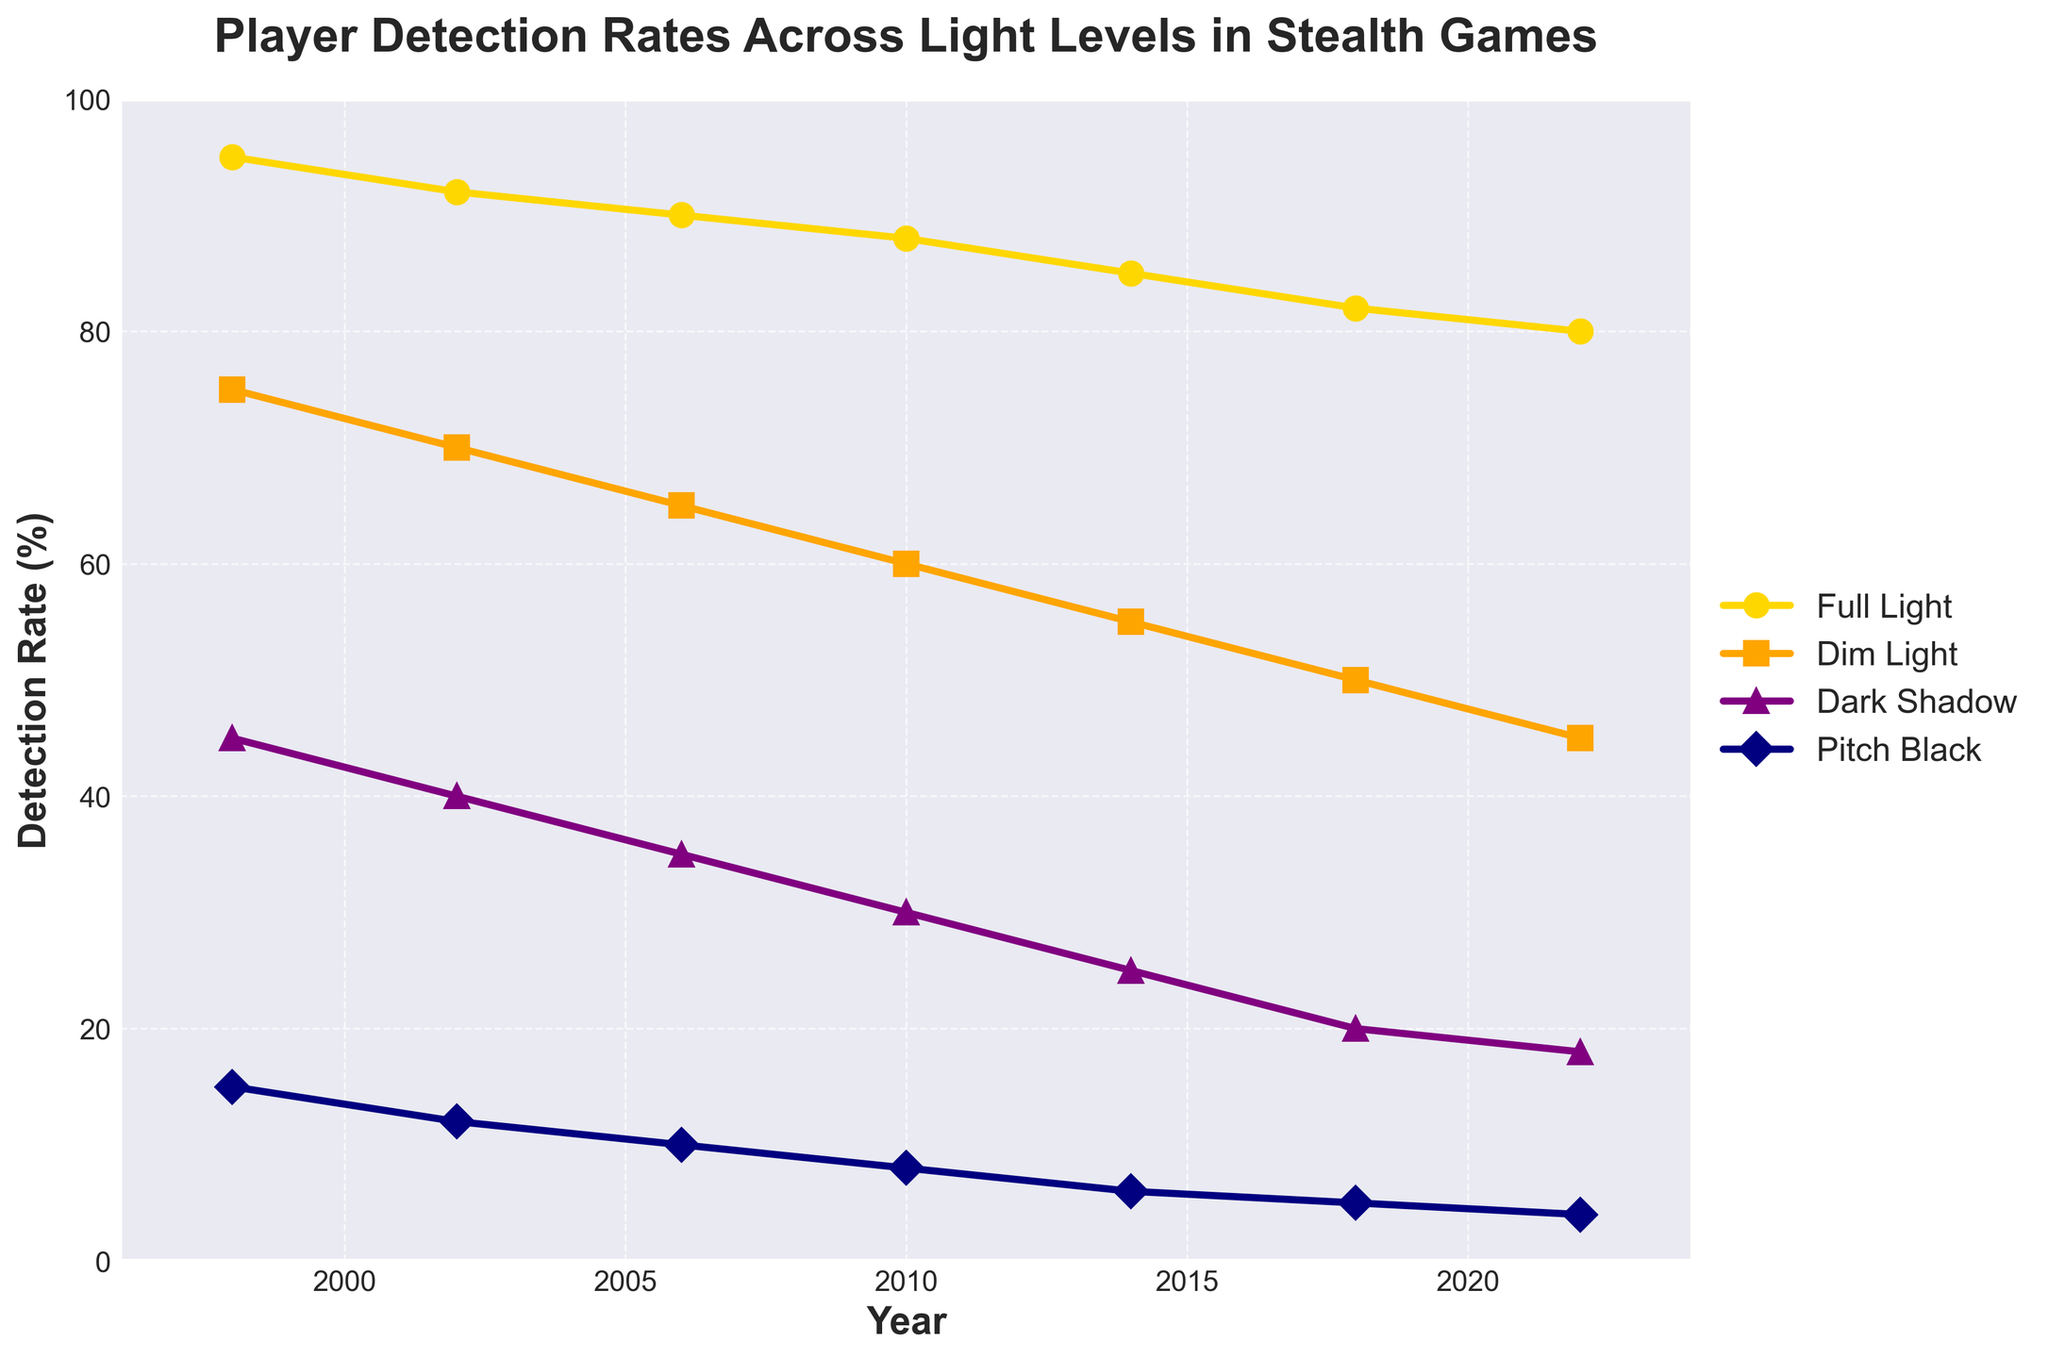What is the detection rate in Full Light and Pitch Black in 1998 combined? To find the combined detection rate for Full Light and Pitch Black in 1998, add the detection rates for these two light levels. Full Light in 1998 is 95%, and Pitch Black in 1998 is 15%. Therefore, the combined detection rate is 95 + 15 = 110.
Answer: 110 Which year had the smallest detection rate difference between Dim Light and Dark Shadow? Calculate the detection rate difference between Dim Light and Dark Shadow for each year and identify the smallest difference. 
- 1998: 75 - 45 = 30
- 2002: 70 - 40 = 30
- 2006: 65 - 35 = 30
- 2010: 60 - 30 = 30
- 2014: 55 - 25 = 30
- 2018: 50 - 20 = 30
- 2022: 45 - 18 = 27 
The smallest difference is in 2022.
Answer: 2022 In which year did the detection rate in Dark Shadow first drop below 30%? Locate the year when Dark Shadow detection rate falls below 30% for the first time. In 2010, the detection rate is 30%, and in 2014, it drops to 25%. Therefore, 2014 is the first year it drops below 30%.
Answer: 2014 Which light level has the steepest decline in detection rate over the given years? Determine the slope of the decline for each light level by subtracting the detection rate from 1998 to 2022 and dividing by the number of years (2022-1998 = 24).
- Full Light: (95 - 80) / 24 = 15 / 24 = 0.625
- Dim Light: (75 - 45) / 24 = 30 / 24 = 1.25
- Dark Shadow: (45 - 18) / 24 = 27 / 24 = 1.125
- Pitch Black: (15 - 4) / 24 = 11 / 24 = 0.458
Dim Light has the steepest decline.
Answer: Dim Light What is the average detection rate in Dark Shadow over the given years? Calculate the average detection rate in Dark Shadow by summing the detection rates and dividing by the number of years.
(45 + 40 + 35 + 30 + 25 + 20 + 18) / 7 = 213 / 7 = 30.43
Answer: 30.43 Was there any year when the detection rate in Dim Light matched Full Light of a previous year? Compare the detection rates of Dim Light for each year with the Full Light rates of previous years.
- 1998: Dim Light 75, Full Light 95 (none match)
- 2002: Dim Light 70, Full Light 92 (none match)
- 2006: Dim Light 65, Full Light 90 (none match)
- 2010: Dim Light 60, Full Light 88 (none match)
- 2014: Dim Light 55, Full Light 85 (none match)
- 2018: Dim Light 50, Full Light 82 (none match)
- 2022: Dim Light 45, Full Light 80 (none match)
There are no matching values.
Answer: None Which light level had the least variation in detection rate over the years? Calculate the range (max - min) of detection rates for each light level to determine the one with the least variation.
- Full Light: max 95 - min 80 = 15
- Dim Light: max 75 - min 45 = 30
- Dark Shadow: max 45 - min 18 = 27
- Pitch Black: max 15 - min 4 = 11
Pitch Black has the least variation with a range of 11.
Answer: Pitch Black Between 1998 and 2006, which light level had the greatest reduction in detection rate? Calculate the reduction in detection rate from 1998 to 2006 for each light level. 
- Full Light: 95 - 90 = 5
- Dim Light: 75 - 65 = 10
- Dark Shadow: 45 - 35 = 10
- Pitch Black: 15 - 10 = 5
Dim Light and Dark Shadow both had the greatest reduction of 10%.
Answer: Dim Light, Dark Shadow 